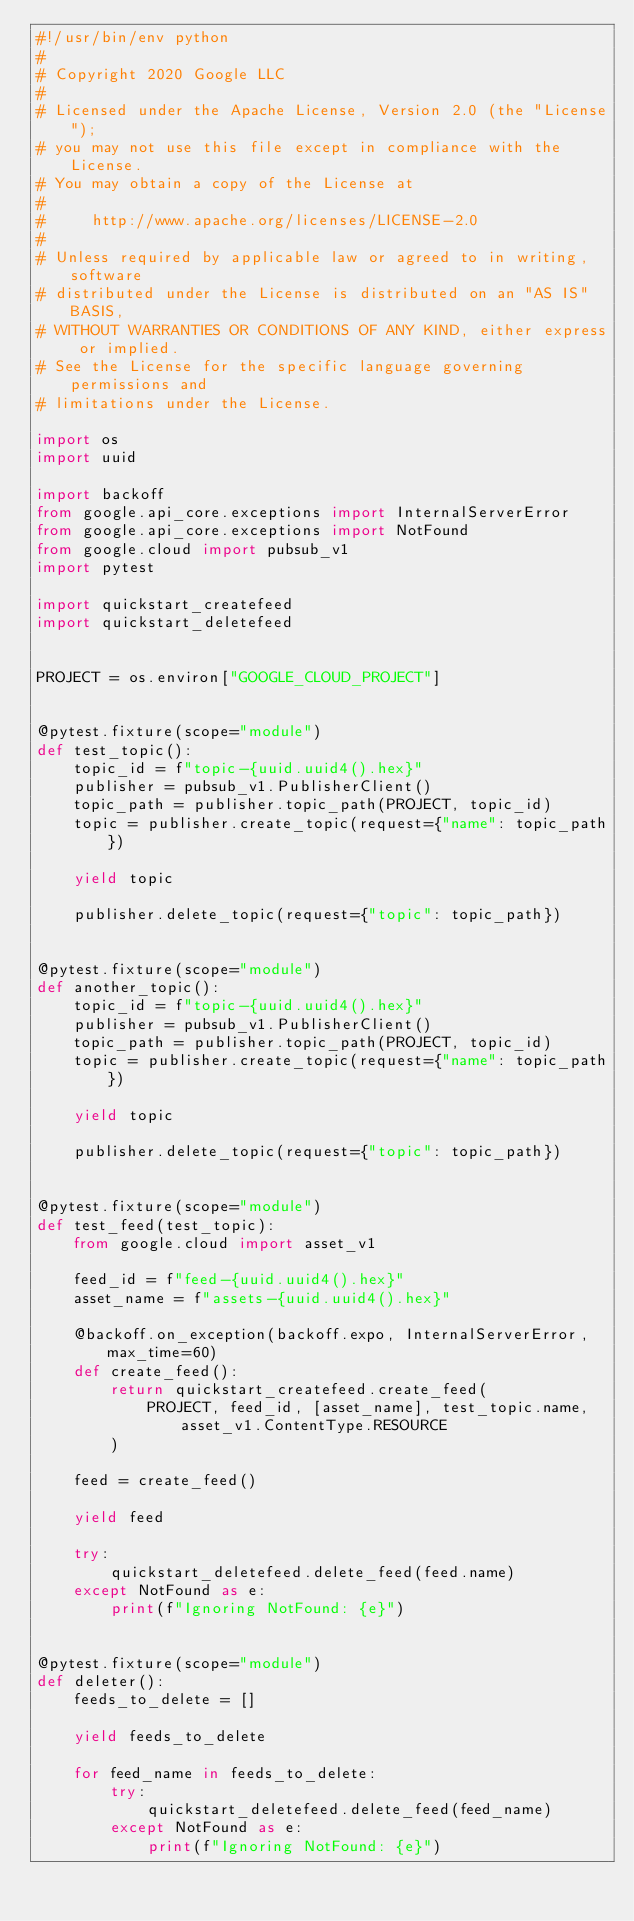<code> <loc_0><loc_0><loc_500><loc_500><_Python_>#!/usr/bin/env python
#
# Copyright 2020 Google LLC
#
# Licensed under the Apache License, Version 2.0 (the "License");
# you may not use this file except in compliance with the License.
# You may obtain a copy of the License at
#
#     http://www.apache.org/licenses/LICENSE-2.0
#
# Unless required by applicable law or agreed to in writing, software
# distributed under the License is distributed on an "AS IS" BASIS,
# WITHOUT WARRANTIES OR CONDITIONS OF ANY KIND, either express or implied.
# See the License for the specific language governing permissions and
# limitations under the License.

import os
import uuid

import backoff
from google.api_core.exceptions import InternalServerError
from google.api_core.exceptions import NotFound
from google.cloud import pubsub_v1
import pytest

import quickstart_createfeed
import quickstart_deletefeed


PROJECT = os.environ["GOOGLE_CLOUD_PROJECT"]


@pytest.fixture(scope="module")
def test_topic():
    topic_id = f"topic-{uuid.uuid4().hex}"
    publisher = pubsub_v1.PublisherClient()
    topic_path = publisher.topic_path(PROJECT, topic_id)
    topic = publisher.create_topic(request={"name": topic_path})

    yield topic

    publisher.delete_topic(request={"topic": topic_path})


@pytest.fixture(scope="module")
def another_topic():
    topic_id = f"topic-{uuid.uuid4().hex}"
    publisher = pubsub_v1.PublisherClient()
    topic_path = publisher.topic_path(PROJECT, topic_id)
    topic = publisher.create_topic(request={"name": topic_path})

    yield topic

    publisher.delete_topic(request={"topic": topic_path})


@pytest.fixture(scope="module")
def test_feed(test_topic):
    from google.cloud import asset_v1

    feed_id = f"feed-{uuid.uuid4().hex}"
    asset_name = f"assets-{uuid.uuid4().hex}"

    @backoff.on_exception(backoff.expo, InternalServerError, max_time=60)
    def create_feed():
        return quickstart_createfeed.create_feed(
            PROJECT, feed_id, [asset_name], test_topic.name, asset_v1.ContentType.RESOURCE
        )

    feed = create_feed()

    yield feed

    try:
        quickstart_deletefeed.delete_feed(feed.name)
    except NotFound as e:
        print(f"Ignoring NotFound: {e}")


@pytest.fixture(scope="module")
def deleter():
    feeds_to_delete = []

    yield feeds_to_delete

    for feed_name in feeds_to_delete:
        try:
            quickstart_deletefeed.delete_feed(feed_name)
        except NotFound as e:
            print(f"Ignoring NotFound: {e}")
</code> 